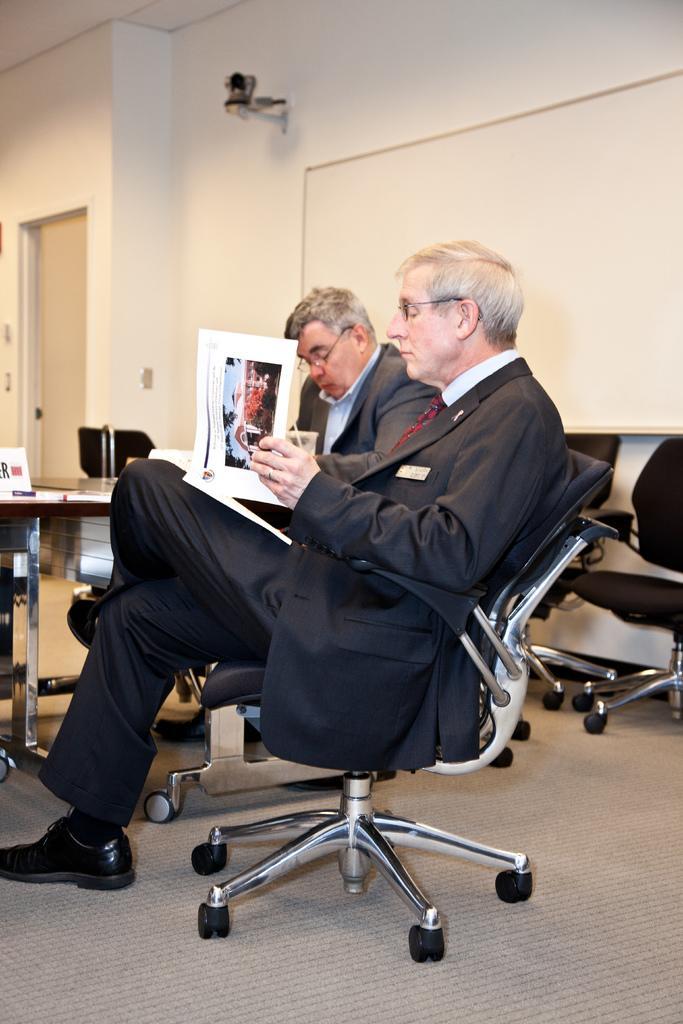Could you give a brief overview of what you see in this image? This picture is clicked inside the room and we can see a person wearing suit, sitting on the chair and holding a book and looking in to the book. In the background we can see the chairs, wall, white color board and a table on the top of which some items are placed and we can see a door and another person wearing suit and sitting on the chair. 